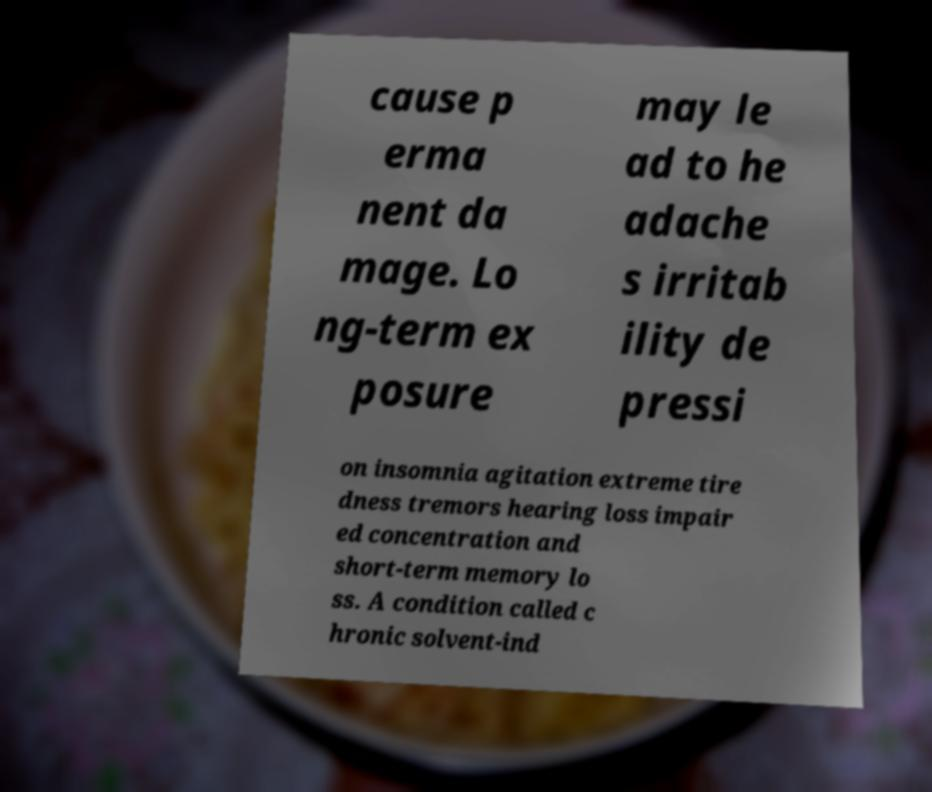Please identify and transcribe the text found in this image. cause p erma nent da mage. Lo ng-term ex posure may le ad to he adache s irritab ility de pressi on insomnia agitation extreme tire dness tremors hearing loss impair ed concentration and short-term memory lo ss. A condition called c hronic solvent-ind 